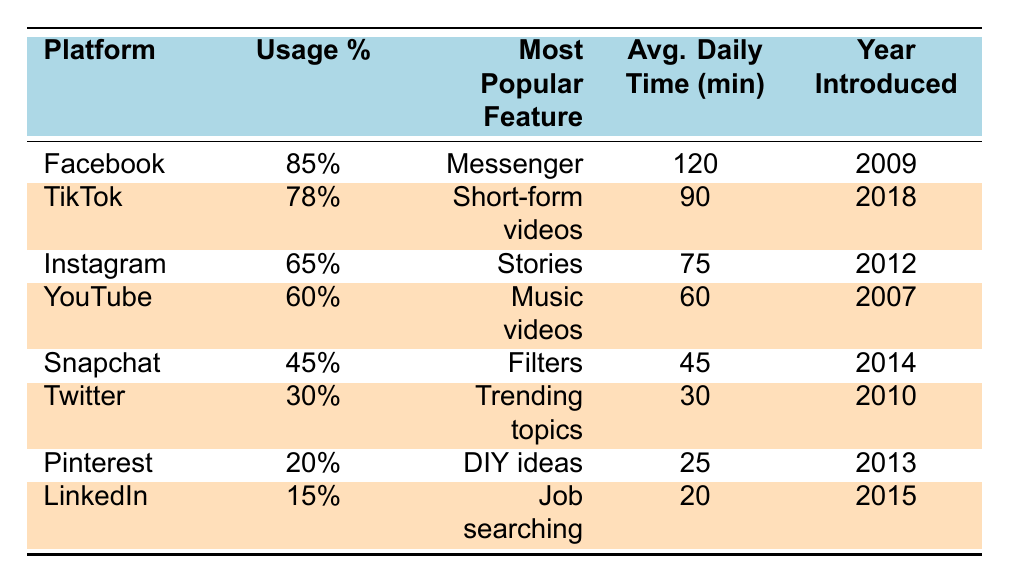What is the most popular social media platform used by Tongan youth? According to the table, Facebook has the highest usage percentage at 85%, making it the most popular platform among Tongan youth.
Answer: Facebook What percentage of Tongan youth use TikTok? The table shows that 78% of Tongan youth use TikTok.
Answer: 78% Which platform's most popular feature is "DIY ideas"? The table indicates that Pinterest has "DIY ideas" as its most popular feature.
Answer: Pinterest What is the average daily time spent on Instagram? The table lists that Tongan youth spend an average of 75 minutes daily on Instagram.
Answer: 75 minutes Which year was YouTube introduced in Tonga? The table states that YouTube was introduced in Tonga in 2007.
Answer: 2007 What is the total usage percentage of Facebook and TikTok combined? Adding the usage percentages of Facebook (85%) and TikTok (78%), gives a total of 163%.
Answer: 163% Among the top three platforms, which has the lowest average daily time spent? The top three platforms are Facebook, TikTok, and Instagram, with average daily times of 120, 90, and 75 minutes respectively. Instagram has the lowest at 75 minutes.
Answer: Instagram Is Snapchat used more than Twitter by Tongan youth? Yes, according to the table, Snapchat has a usage percentage of 45%, while Twitter only has 30%, indicating that Snapchat is more used than Twitter.
Answer: Yes What is the average daily time spent on the four most popular platforms? The average daily time spent on Facebook (120), TikTok (90), Instagram (75), and YouTube (60) is (120 + 90 + 75 + 60) / 4 = 86.25 minutes.
Answer: 86.25 minutes In which year was LinkedIn introduced in Tonga compared to the year Instagram was introduced? LinkedIn was introduced in 2015 whereas Instagram was introduced in 2012, making LinkedIn three years later than Instagram.
Answer: 3 years later Which platform has the highest daily average time spent and what is that time? The table shows that Facebook has the highest daily average time at 120 minutes spent by Tongan youth.
Answer: 120 minutes 